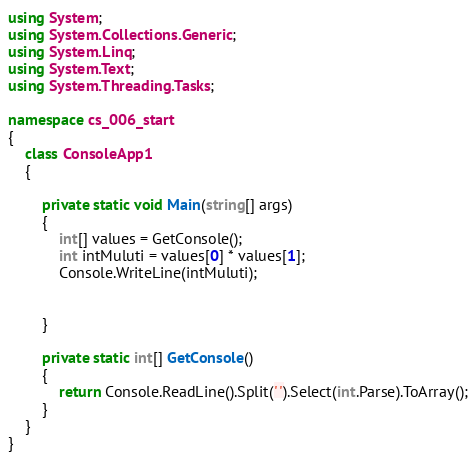<code> <loc_0><loc_0><loc_500><loc_500><_C#_>using System;
using System.Collections.Generic;
using System.Linq;
using System.Text;
using System.Threading.Tasks;

namespace cs_006_start
{
    class ConsoleApp1
    {
        
        private static void Main(string[] args)
        {
            int[] values = GetConsole();
            int intMuluti = values[0] * values[1];
            Console.WriteLine(intMuluti);


        }

        private static int[] GetConsole()
        {
            return Console.ReadLine().Split(' ').Select(int.Parse).ToArray();
        }
    }
}
</code> 